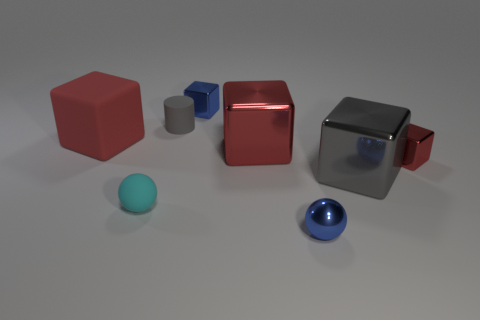Are there any reflections or shadows that provide clues about the lighting in this scene? Yes, the visible shadows and reflections, particularly on the shiny red and gray cubes, suggest a lighting source above the objects, slightly to the left, creating soft shadows that trail off to the right, indicating a soft and diffuse light source. 